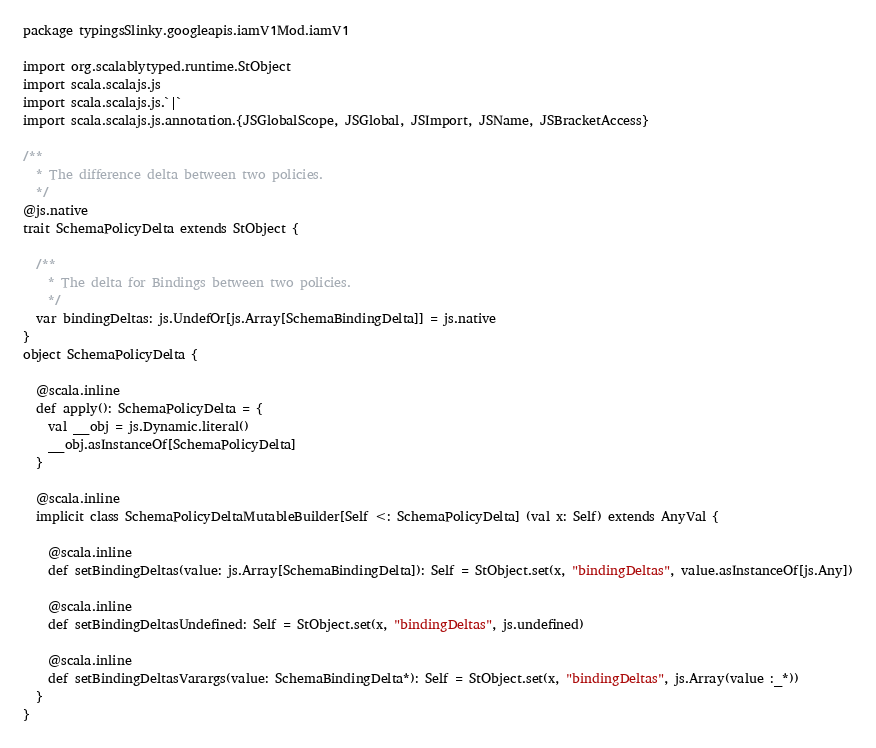Convert code to text. <code><loc_0><loc_0><loc_500><loc_500><_Scala_>package typingsSlinky.googleapis.iamV1Mod.iamV1

import org.scalablytyped.runtime.StObject
import scala.scalajs.js
import scala.scalajs.js.`|`
import scala.scalajs.js.annotation.{JSGlobalScope, JSGlobal, JSImport, JSName, JSBracketAccess}

/**
  * The difference delta between two policies.
  */
@js.native
trait SchemaPolicyDelta extends StObject {
  
  /**
    * The delta for Bindings between two policies.
    */
  var bindingDeltas: js.UndefOr[js.Array[SchemaBindingDelta]] = js.native
}
object SchemaPolicyDelta {
  
  @scala.inline
  def apply(): SchemaPolicyDelta = {
    val __obj = js.Dynamic.literal()
    __obj.asInstanceOf[SchemaPolicyDelta]
  }
  
  @scala.inline
  implicit class SchemaPolicyDeltaMutableBuilder[Self <: SchemaPolicyDelta] (val x: Self) extends AnyVal {
    
    @scala.inline
    def setBindingDeltas(value: js.Array[SchemaBindingDelta]): Self = StObject.set(x, "bindingDeltas", value.asInstanceOf[js.Any])
    
    @scala.inline
    def setBindingDeltasUndefined: Self = StObject.set(x, "bindingDeltas", js.undefined)
    
    @scala.inline
    def setBindingDeltasVarargs(value: SchemaBindingDelta*): Self = StObject.set(x, "bindingDeltas", js.Array(value :_*))
  }
}
</code> 